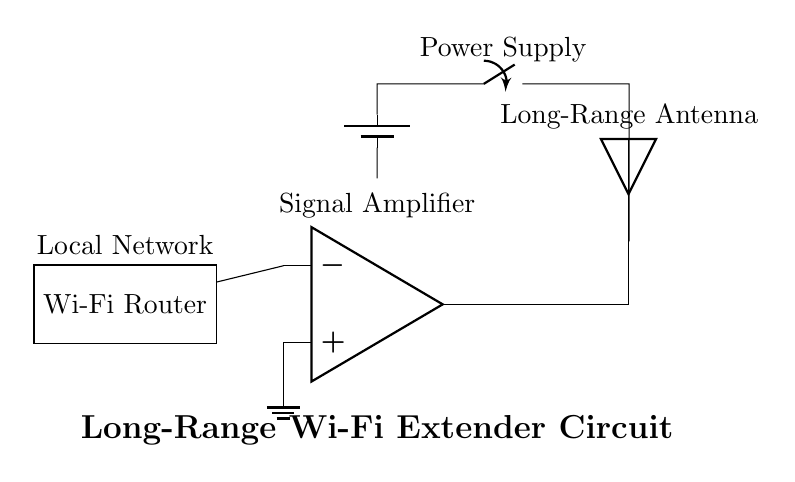What is the main component providing amplification in the circuit? The amplifier, represented by the operational amplifier symbol, is the component that increases signal strength in the circuit.
Answer: amplifier What is the purpose of the long-range antenna in this circuit? The long-range antenna is designed to transmit and receive Wi-Fi signals over a greater distance, improving connectivity in rural areas.
Answer: transmit and receive signals Which component supplies power to the circuit? The power supply, depicted as a battery symbol, provides the necessary energy for the circuit to function properly.
Answer: battery How many components are involved in the signal path from the Wi-Fi router to the antenna? There are three key components in the signal path: the Wi-Fi router, the amplifier, and the long-range antenna.
Answer: three What type of circuit is this diagram illustrating? This is a communication circuit designed to extend Wi-Fi coverage, making it suitable for areas with limited connectivity.
Answer: communication circuit What is the placement of the ground in this circuit? The ground is connected to the positive input of the amplifier, ensuring a reference point for the circuit and stability in the signal processing.
Answer: at the amplifier input 